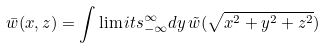<formula> <loc_0><loc_0><loc_500><loc_500>\bar { w } ( x , z ) = \int \lim i t s _ { - \infty } ^ { \infty } d y \, \tilde { w } ( \sqrt { x ^ { 2 } + y ^ { 2 } + z ^ { 2 } } )</formula> 